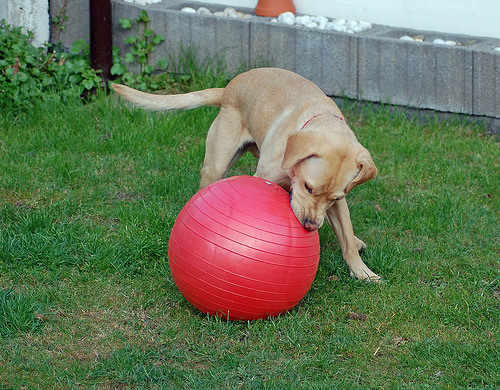<image>
Can you confirm if the dog is on the ball? No. The dog is not positioned on the ball. They may be near each other, but the dog is not supported by or resting on top of the ball. Is there a ball under the wall? No. The ball is not positioned under the wall. The vertical relationship between these objects is different. Where is the dog in relation to the ball? Is it next to the ball? Yes. The dog is positioned adjacent to the ball, located nearby in the same general area. 